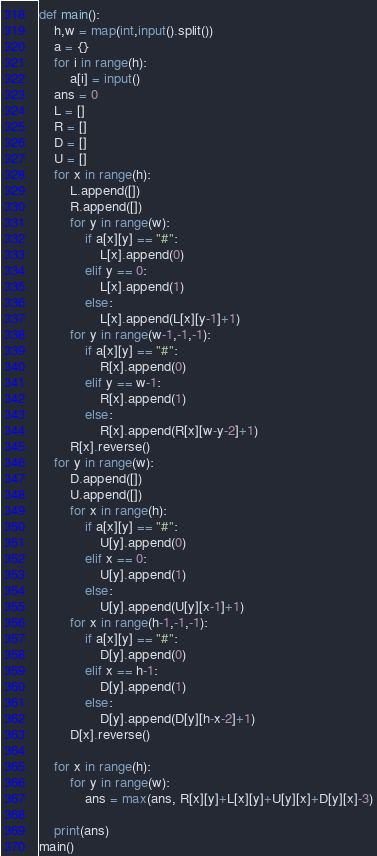Convert code to text. <code><loc_0><loc_0><loc_500><loc_500><_Python_>def main():
    h,w = map(int,input().split())
    a = {}
    for i in range(h):
        a[i] = input()
    ans = 0
    L = []
    R = []
    D = []
    U = []
    for x in range(h):
        L.append([])
        R.append([])
        for y in range(w):
            if a[x][y] == "#":
                L[x].append(0)
            elif y == 0:
                L[x].append(1)
            else:
                L[x].append(L[x][y-1]+1)
        for y in range(w-1,-1,-1):
            if a[x][y] == "#":
                R[x].append(0)
            elif y == w-1:
                R[x].append(1)
            else:
                R[x].append(R[x][w-y-2]+1)
        R[x].reverse()
    for y in range(w):
        D.append([])
        U.append([])
        for x in range(h):
            if a[x][y] == "#":
                U[y].append(0)
            elif x == 0:
                U[y].append(1)
            else:
                U[y].append(U[y][x-1]+1)
        for x in range(h-1,-1,-1):
            if a[x][y] == "#":
                D[y].append(0)
            elif x == h-1:
                D[y].append(1)
            else:
                D[y].append(D[y][h-x-2]+1)
        D[x].reverse()

    for x in range(h):
        for y in range(w):
            ans = max(ans, R[x][y]+L[x][y]+U[y][x]+D[y][x]-3)
            
    print(ans)
main()
</code> 